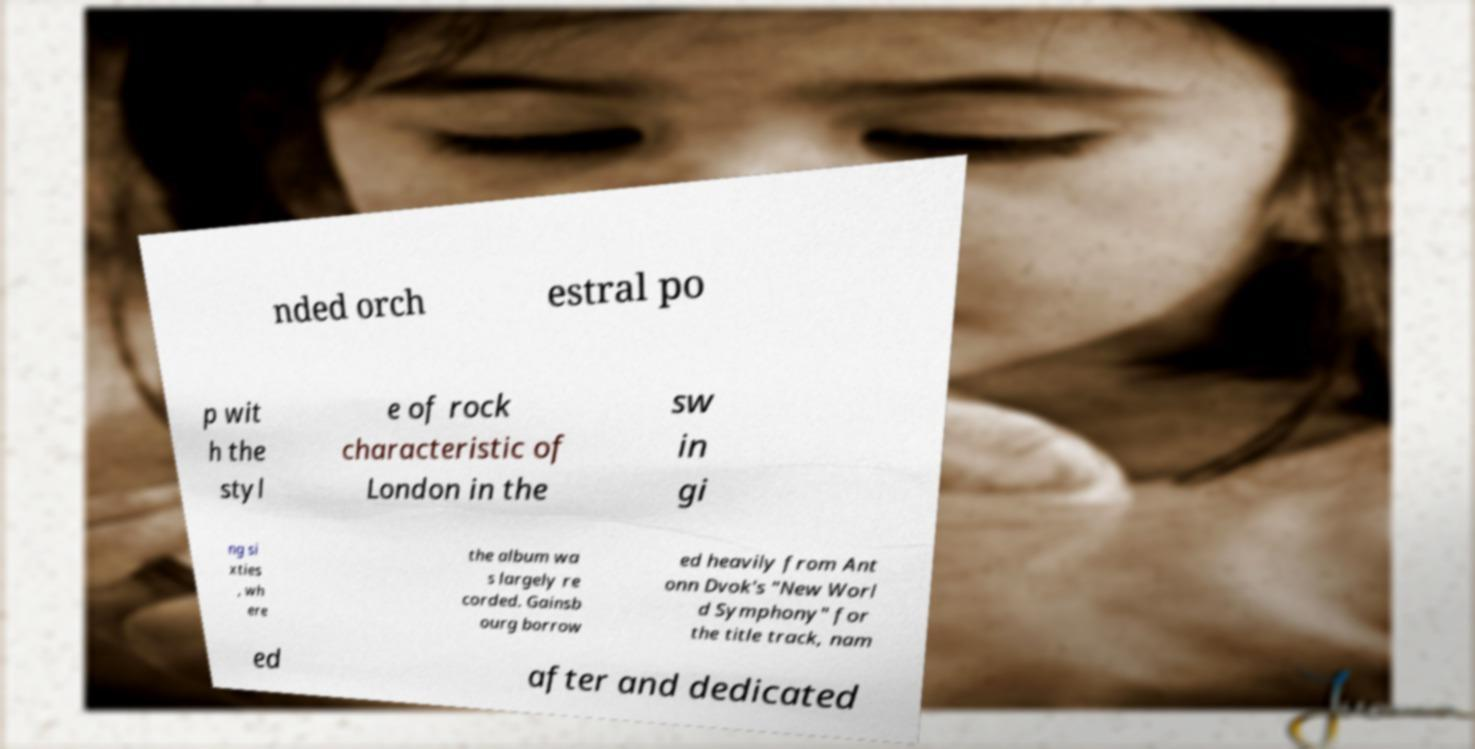Could you assist in decoding the text presented in this image and type it out clearly? nded orch estral po p wit h the styl e of rock characteristic of London in the sw in gi ng si xties , wh ere the album wa s largely re corded. Gainsb ourg borrow ed heavily from Ant onn Dvok's "New Worl d Symphony" for the title track, nam ed after and dedicated 